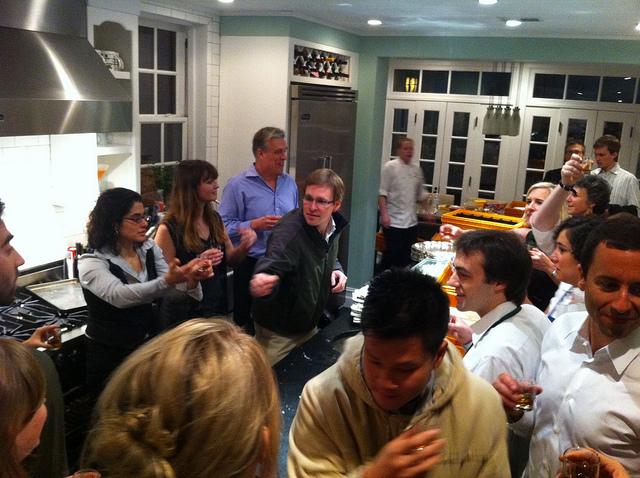What is the blonde lady's hairstyle?
Quick response, please. Bun. Do the students have laptops?
Be succinct. No. Is the room full?
Write a very short answer. Yes. Is this a party?
Be succinct. Yes. 